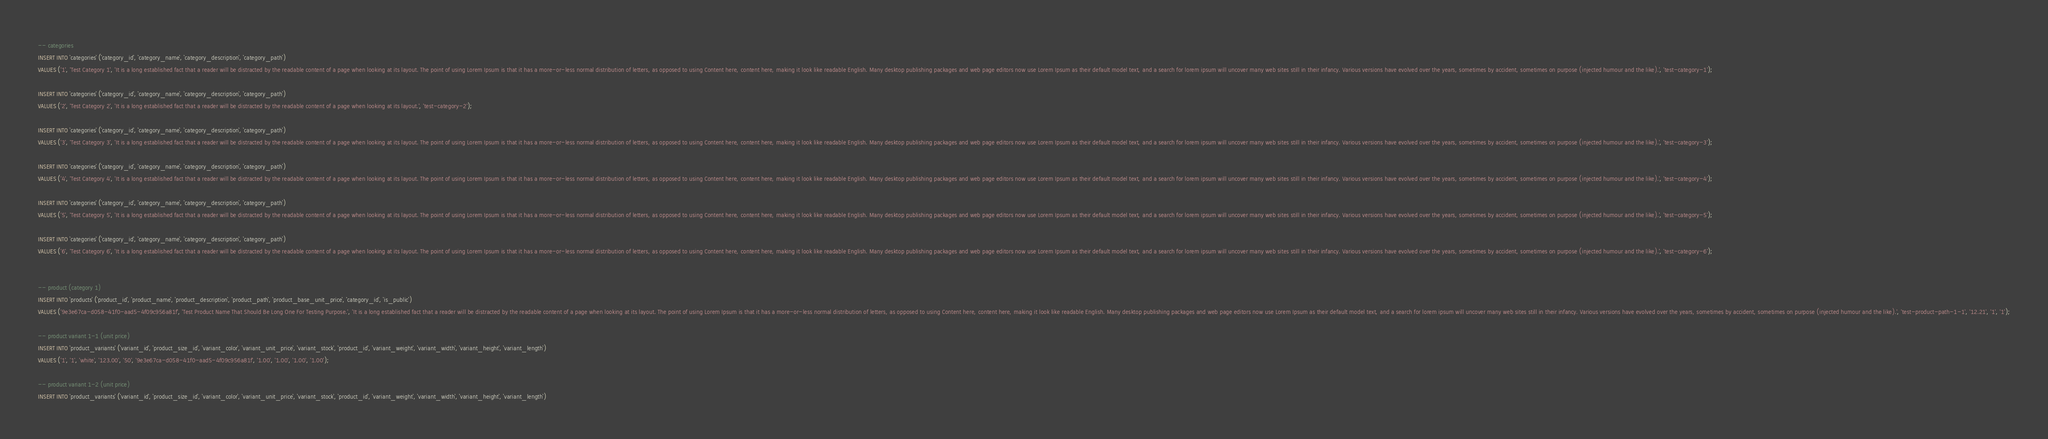<code> <loc_0><loc_0><loc_500><loc_500><_SQL_>-- categories
INSERT INTO `categories` (`category_id`, `category_name`, `category_description`, `category_path`)
VALUES ('1', 'Test Category 1', 'It is a long established fact that a reader will be distracted by the readable content of a page when looking at its layout. The point of using Lorem Ipsum is that it has a more-or-less normal distribution of letters, as opposed to using Content here, content here, making it look like readable English. Many desktop publishing packages and web page editors now use Lorem Ipsum as their default model text, and a search for lorem ipsum will uncover many web sites still in their infancy. Various versions have evolved over the years, sometimes by accident, sometimes on purpose (injected humour and the like).', 'test-category-1');

INSERT INTO `categories` (`category_id`, `category_name`, `category_description`, `category_path`)
VALUES ('2', 'Test Category 2', 'It is a long established fact that a reader will be distracted by the readable content of a page when looking at its layout.', 'test-category-2');

INSERT INTO `categories` (`category_id`, `category_name`, `category_description`, `category_path`)
VALUES ('3', 'Test Category 3', 'It is a long established fact that a reader will be distracted by the readable content of a page when looking at its layout. The point of using Lorem Ipsum is that it has a more-or-less normal distribution of letters, as opposed to using Content here, content here, making it look like readable English. Many desktop publishing packages and web page editors now use Lorem Ipsum as their default model text, and a search for lorem ipsum will uncover many web sites still in their infancy. Various versions have evolved over the years, sometimes by accident, sometimes on purpose (injected humour and the like).', 'test-category-3');

INSERT INTO `categories` (`category_id`, `category_name`, `category_description`, `category_path`)
VALUES ('4', 'Test Category 4', 'It is a long established fact that a reader will be distracted by the readable content of a page when looking at its layout. The point of using Lorem Ipsum is that it has a more-or-less normal distribution of letters, as opposed to using Content here, content here, making it look like readable English. Many desktop publishing packages and web page editors now use Lorem Ipsum as their default model text, and a search for lorem ipsum will uncover many web sites still in their infancy. Various versions have evolved over the years, sometimes by accident, sometimes on purpose (injected humour and the like).', 'test-category-4');

INSERT INTO `categories` (`category_id`, `category_name`, `category_description`, `category_path`)
VALUES ('5', 'Test Category 5', 'It is a long established fact that a reader will be distracted by the readable content of a page when looking at its layout. The point of using Lorem Ipsum is that it has a more-or-less normal distribution of letters, as opposed to using Content here, content here, making it look like readable English. Many desktop publishing packages and web page editors now use Lorem Ipsum as their default model text, and a search for lorem ipsum will uncover many web sites still in their infancy. Various versions have evolved over the years, sometimes by accident, sometimes on purpose (injected humour and the like).', 'test-category-5');

INSERT INTO `categories` (`category_id`, `category_name`, `category_description`, `category_path`)
VALUES ('6', 'Test Category 6', 'It is a long established fact that a reader will be distracted by the readable content of a page when looking at its layout. The point of using Lorem Ipsum is that it has a more-or-less normal distribution of letters, as opposed to using Content here, content here, making it look like readable English. Many desktop publishing packages and web page editors now use Lorem Ipsum as their default model text, and a search for lorem ipsum will uncover many web sites still in their infancy. Various versions have evolved over the years, sometimes by accident, sometimes on purpose (injected humour and the like).', 'test-category-6');


-- product (category 1)
INSERT INTO `products` (`product_id`, `product_name`, `product_description`, `product_path`, `product_base_unit_price`, `category_id`, `is_public`)
VALUES ('9e3e67ca-d058-41f0-aad5-4f09c956a81f', 'Test Product Name That Should Be Long One For Testing Purpose.', 'It is a long established fact that a reader will be distracted by the readable content of a page when looking at its layout. The point of using Lorem Ipsum is that it has a more-or-less normal distribution of letters, as opposed to using Content here, content here, making it look like readable English. Many desktop publishing packages and web page editors now use Lorem Ipsum as their default model text, and a search for lorem ipsum will uncover many web sites still in their infancy. Various versions have evolved over the years, sometimes by accident, sometimes on purpose (injected humour and the like).', 'test-product-path-1-1', '12.21', '1', '1');

-- product variant 1-1 (unit price)
INSERT INTO `product_variants` (`variant_id`, `product_size_id`, `variant_color`, `variant_unit_price`, `variant_stock`, `product_id`, `variant_weight`, `variant_width`, `variant_height`, `variant_length`)
VALUES ('1', '1', 'white', '123.00', '50', '9e3e67ca-d058-41f0-aad5-4f09c956a81f', '1.00', '1.00', '1.00', '1.00');

-- product variant 1-2 (unit price)
INSERT INTO `product_variants` (`variant_id`, `product_size_id`, `variant_color`, `variant_unit_price`, `variant_stock`, `product_id`, `variant_weight`, `variant_width`, `variant_height`, `variant_length`)</code> 